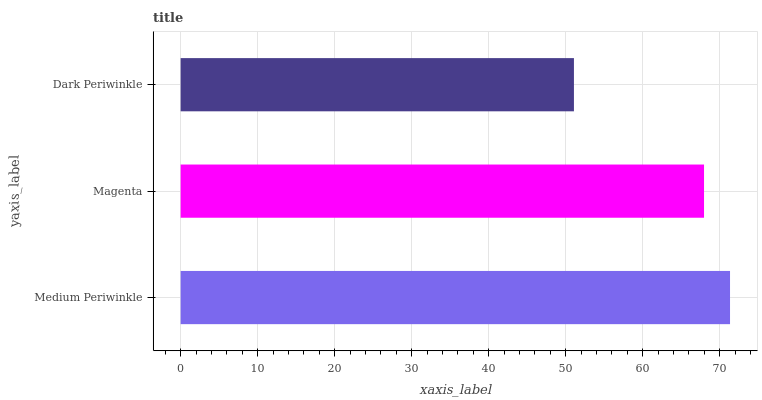Is Dark Periwinkle the minimum?
Answer yes or no. Yes. Is Medium Periwinkle the maximum?
Answer yes or no. Yes. Is Magenta the minimum?
Answer yes or no. No. Is Magenta the maximum?
Answer yes or no. No. Is Medium Periwinkle greater than Magenta?
Answer yes or no. Yes. Is Magenta less than Medium Periwinkle?
Answer yes or no. Yes. Is Magenta greater than Medium Periwinkle?
Answer yes or no. No. Is Medium Periwinkle less than Magenta?
Answer yes or no. No. Is Magenta the high median?
Answer yes or no. Yes. Is Magenta the low median?
Answer yes or no. Yes. Is Dark Periwinkle the high median?
Answer yes or no. No. Is Dark Periwinkle the low median?
Answer yes or no. No. 